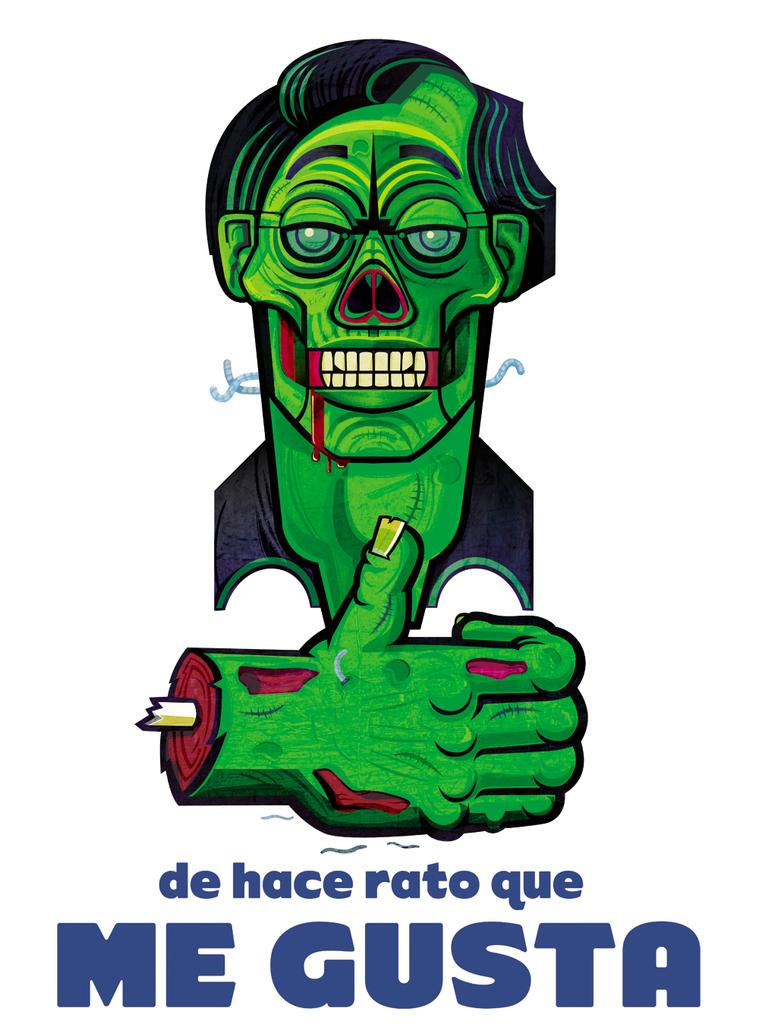<image>
Provide a brief description of the given image. A poster with a zombie on it says Me Gusta. 